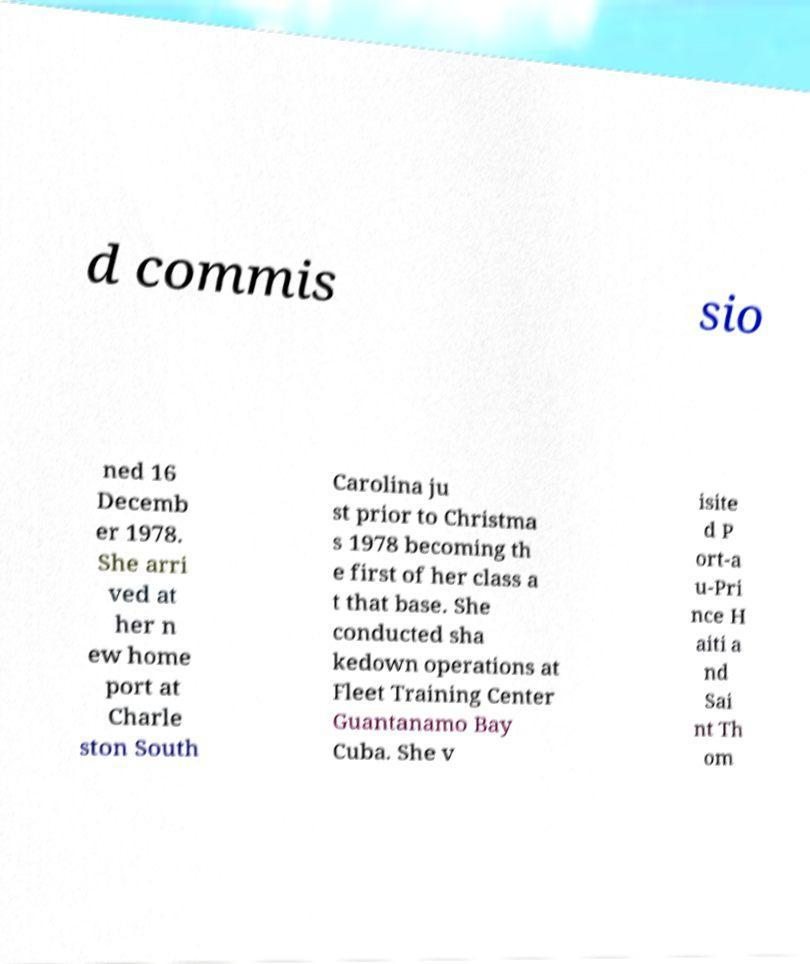Could you assist in decoding the text presented in this image and type it out clearly? d commis sio ned 16 Decemb er 1978. She arri ved at her n ew home port at Charle ston South Carolina ju st prior to Christma s 1978 becoming th e first of her class a t that base. She conducted sha kedown operations at Fleet Training Center Guantanamo Bay Cuba. She v isite d P ort-a u-Pri nce H aiti a nd Sai nt Th om 